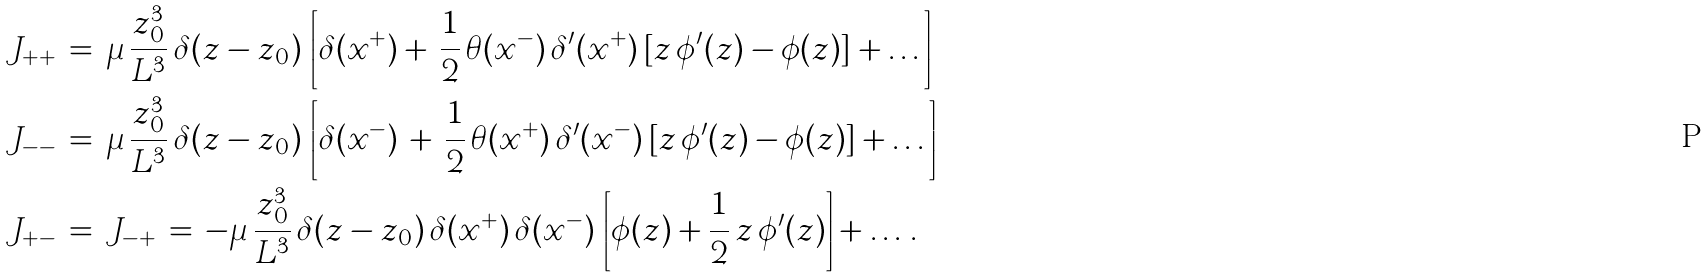Convert formula to latex. <formula><loc_0><loc_0><loc_500><loc_500>J _ { + + } \, & = \, \mu \, \frac { z _ { 0 } ^ { 3 } } { L ^ { 3 } } \, \delta ( z - z _ { 0 } ) \, \left [ \delta ( x ^ { + } ) + \, \frac { 1 } { 2 } \, \theta ( x ^ { - } ) \, \delta ^ { \prime } ( x ^ { + } ) \, [ z \, \phi ^ { \prime } ( z ) - \phi ( z ) ] + \dots \right ] \\ J _ { - - } \, & = \, \mu \, \frac { z _ { 0 } ^ { 3 } } { L ^ { 3 } } \, \delta ( z - z _ { 0 } ) \, \left [ \delta ( x ^ { - } ) \, + \, \frac { 1 } { 2 } \, \theta ( x ^ { + } ) \, \delta ^ { \prime } ( x ^ { - } ) \, [ z \, \phi ^ { \prime } ( z ) - \phi ( z ) ] + \dots \right ] \\ J _ { + - } \, & = \, J _ { - + } \, = \, - \mu \, \frac { z _ { 0 } ^ { 3 } } { L ^ { 3 } } \, \delta ( z - z _ { 0 } ) \, \delta ( x ^ { + } ) \, \delta ( x ^ { - } ) \, \left [ \phi ( z ) + \frac { 1 } { 2 } \, z \, \phi ^ { \prime } ( z ) \right ] + \dots \, .</formula> 